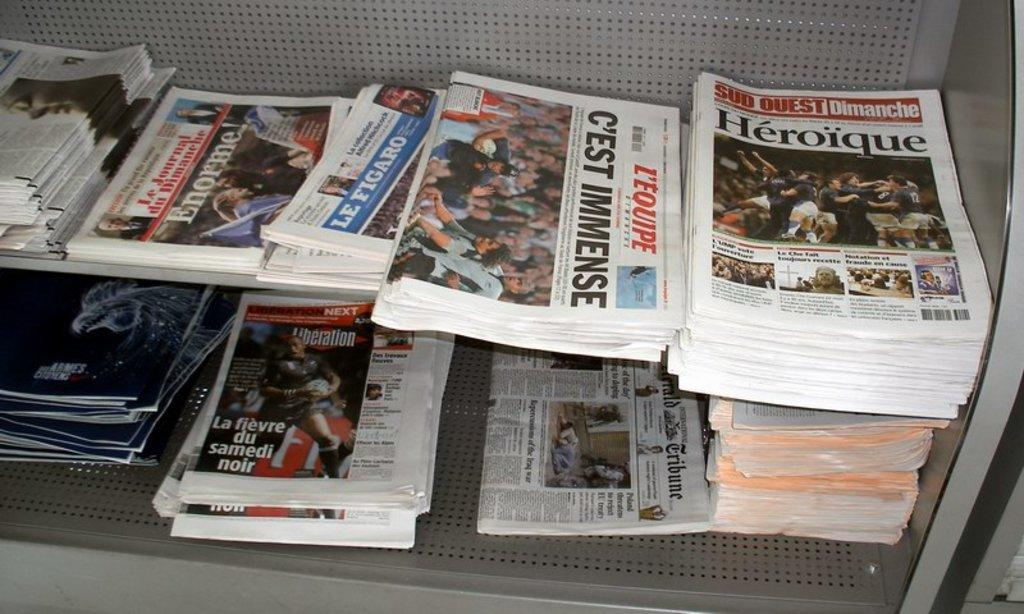<image>
Render a clear and concise summary of the photo. Stacks of french newspapers including one that says Heroique 